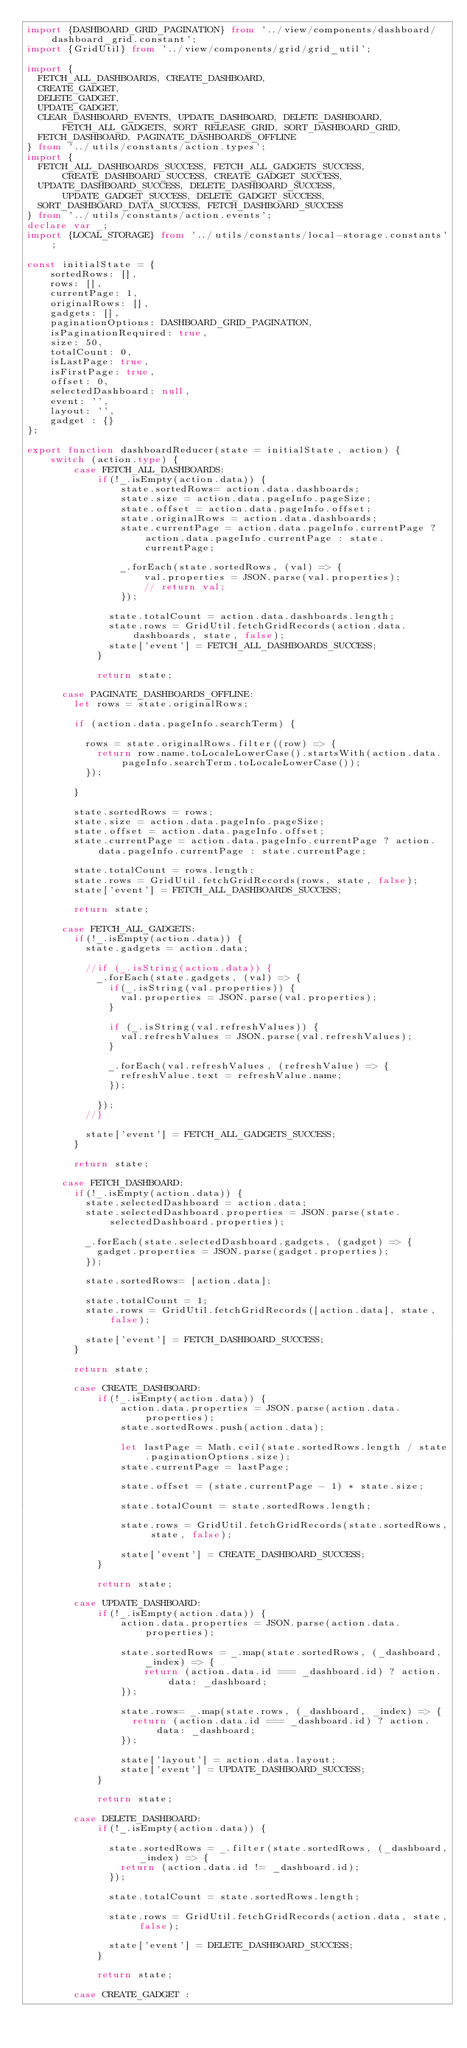Convert code to text. <code><loc_0><loc_0><loc_500><loc_500><_TypeScript_>import {DASHBOARD_GRID_PAGINATION} from '../view/components/dashboard/dashboard_grid.constant';
import {GridUtil} from '../view/components/grid/grid_util';

import {
  FETCH_ALL_DASHBOARDS, CREATE_DASHBOARD,
  CREATE_GADGET,
  DELETE_GADGET,
  UPDATE_GADGET,
  CLEAR_DASHBOARD_EVENTS, UPDATE_DASHBOARD, DELETE_DASHBOARD, FETCH_ALL_GADGETS, SORT_RELEASE_GRID, SORT_DASHBOARD_GRID,
  FETCH_DASHBOARD, PAGINATE_DASHBOARDS_OFFLINE
} from '../utils/constants/action.types';
import {
  FETCH_ALL_DASHBOARDS_SUCCESS, FETCH_ALL_GADGETS_SUCCESS, CREATE_DASHBOARD_SUCCESS, CREATE_GADGET_SUCCESS,
  UPDATE_DASHBOARD_SUCCESS, DELETE_DASHBOARD_SUCCESS, UPDATE_GADGET_SUCCESS, DELETE_GADGET_SUCCESS,
  SORT_DASHBOARD_DATA_SUCCESS, FETCH_DASHBOARD_SUCCESS
} from '../utils/constants/action.events';
declare var _;
import {LOCAL_STORAGE} from '../utils/constants/local-storage.constants';

const initialState = {
    sortedRows: [],
    rows: [],
    currentPage: 1,
    originalRows: [],
    gadgets: [],
    paginationOptions: DASHBOARD_GRID_PAGINATION,
    isPaginationRequired: true,
    size: 50,
    totalCount: 0,
    isLastPage: true,
    isFirstPage: true,
    offset: 0,
    selectedDashboard: null,
    event: '',
    layout: '',
    gadget : {}
};

export function dashboardReducer(state = initialState, action) {
    switch (action.type) {
        case FETCH_ALL_DASHBOARDS:
            if(!_.isEmpty(action.data)) {
                state.sortedRows= action.data.dashboards;
                state.size = action.data.pageInfo.pageSize;
                state.offset = action.data.pageInfo.offset;
                state.originalRows = action.data.dashboards;
                state.currentPage = action.data.pageInfo.currentPage ? action.data.pageInfo.currentPage : state.currentPage;

                _.forEach(state.sortedRows, (val) => {
                    val.properties = JSON.parse(val.properties);
                    // return val;
                });

              state.totalCount = action.data.dashboards.length;
              state.rows = GridUtil.fetchGridRecords(action.data.dashboards, state, false);
              state['event'] = FETCH_ALL_DASHBOARDS_SUCCESS;
            }

            return state;

      case PAGINATE_DASHBOARDS_OFFLINE:
        let rows = state.originalRows;

        if (action.data.pageInfo.searchTerm) {

          rows = state.originalRows.filter((row) => {
            return row.name.toLocaleLowerCase().startsWith(action.data.pageInfo.searchTerm.toLocaleLowerCase());
          });

        }

        state.sortedRows = rows;
        state.size = action.data.pageInfo.pageSize;
        state.offset = action.data.pageInfo.offset;
        state.currentPage = action.data.pageInfo.currentPage ? action.data.pageInfo.currentPage : state.currentPage;

        state.totalCount = rows.length;
        state.rows = GridUtil.fetchGridRecords(rows, state, false);
        state['event'] = FETCH_ALL_DASHBOARDS_SUCCESS;

        return state;

      case FETCH_ALL_GADGETS:
        if(!_.isEmpty(action.data)) {
          state.gadgets = action.data;

          //if (_.isString(action.data)) {
            _.forEach(state.gadgets, (val) => {
              if(_.isString(val.properties)) {
                val.properties = JSON.parse(val.properties);
              }

              if (_.isString(val.refreshValues)) {
                val.refreshValues = JSON.parse(val.refreshValues);
              }

              _.forEach(val.refreshValues, (refreshValue) => {
                refreshValue.text = refreshValue.name;
              });

            });
          //}

          state['event'] = FETCH_ALL_GADGETS_SUCCESS;
        }

        return state;

      case FETCH_DASHBOARD:
        if(!_.isEmpty(action.data)) {
          state.selectedDashboard = action.data;
          state.selectedDashboard.properties = JSON.parse(state.selectedDashboard.properties);

          _.forEach(state.selectedDashboard.gadgets, (gadget) => {
            gadget.properties = JSON.parse(gadget.properties);
          });

          state.sortedRows= [action.data];

          state.totalCount = 1;
          state.rows = GridUtil.fetchGridRecords([action.data], state, false);

          state['event'] = FETCH_DASHBOARD_SUCCESS;
        }

        return state;

        case CREATE_DASHBOARD:
            if(!_.isEmpty(action.data)) {
                action.data.properties = JSON.parse(action.data.properties);
                state.sortedRows.push(action.data);

                let lastPage = Math.ceil(state.sortedRows.length / state.paginationOptions.size);
                state.currentPage = lastPage;

                state.offset = (state.currentPage - 1) * state.size;

                state.totalCount = state.sortedRows.length;

                state.rows = GridUtil.fetchGridRecords(state.sortedRows, state, false);

                state['event'] = CREATE_DASHBOARD_SUCCESS;
            }

            return state;

        case UPDATE_DASHBOARD:
            if(!_.isEmpty(action.data)) {
                action.data.properties = JSON.parse(action.data.properties);

                state.sortedRows = _.map(state.sortedRows, (_dashboard, _index) => {
                    return (action.data.id === _dashboard.id) ? action.data: _dashboard;
                });

                state.rows= _.map(state.rows, (_dashboard, _index) => {
                  return (action.data.id === _dashboard.id) ? action.data: _dashboard;
                });

                state['layout'] = action.data.layout;
                state['event'] = UPDATE_DASHBOARD_SUCCESS;
            }

            return state;

        case DELETE_DASHBOARD:
            if(!_.isEmpty(action.data)) {

              state.sortedRows = _.filter(state.sortedRows, (_dashboard, _index) => {
                return (action.data.id != _dashboard.id);
              });

              state.totalCount = state.sortedRows.length;

              state.rows = GridUtil.fetchGridRecords(action.data, state, false);

              state['event'] = DELETE_DASHBOARD_SUCCESS;
            }

            return state;

        case CREATE_GADGET :</code> 